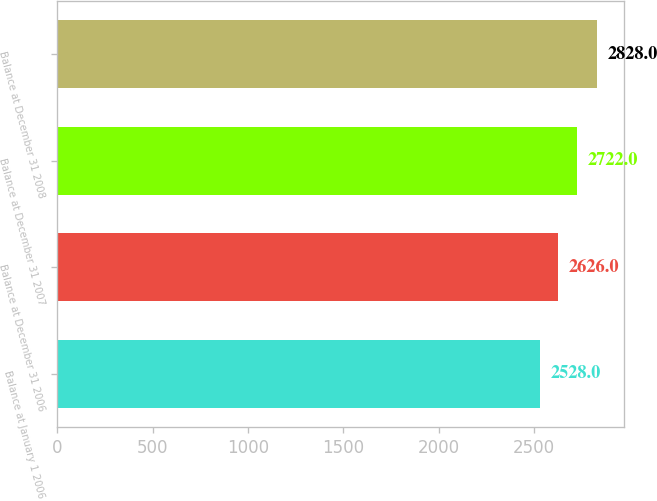<chart> <loc_0><loc_0><loc_500><loc_500><bar_chart><fcel>Balance at January 1 2006<fcel>Balance at December 31 2006<fcel>Balance at December 31 2007<fcel>Balance at December 31 2008<nl><fcel>2528<fcel>2626<fcel>2722<fcel>2828<nl></chart> 